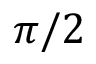<formula> <loc_0><loc_0><loc_500><loc_500>\pi / 2</formula> 